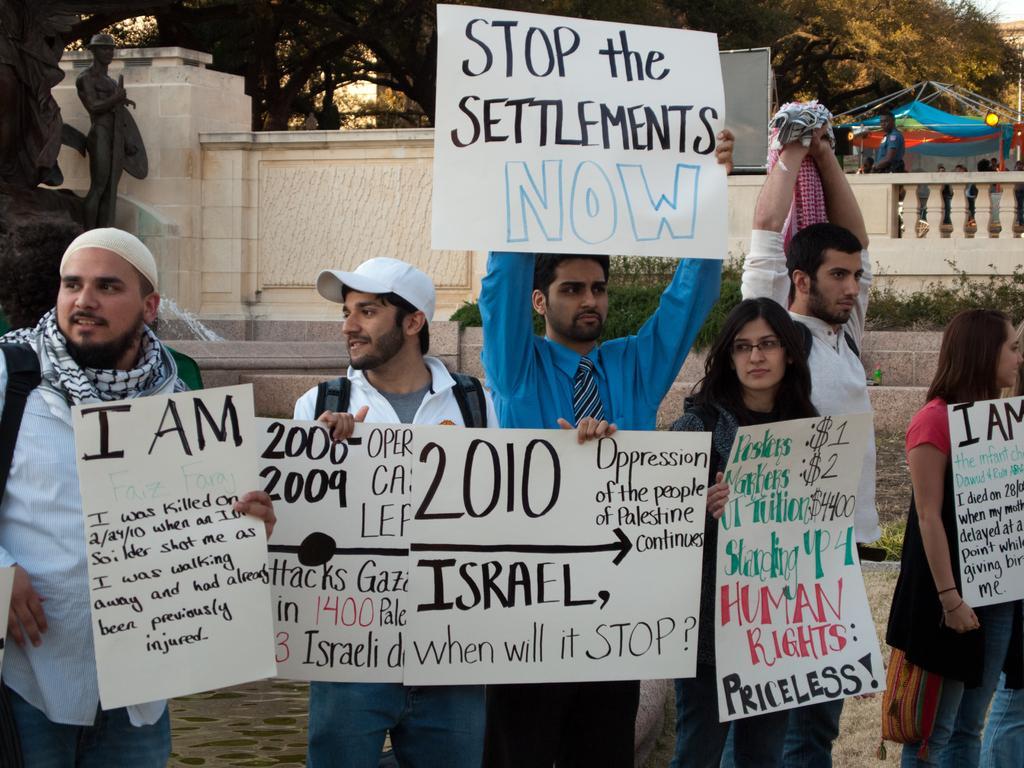Can you describe this image briefly? In this picture there are few persons standing and holding a white sheet which has something written on it and there are trees in the background. 